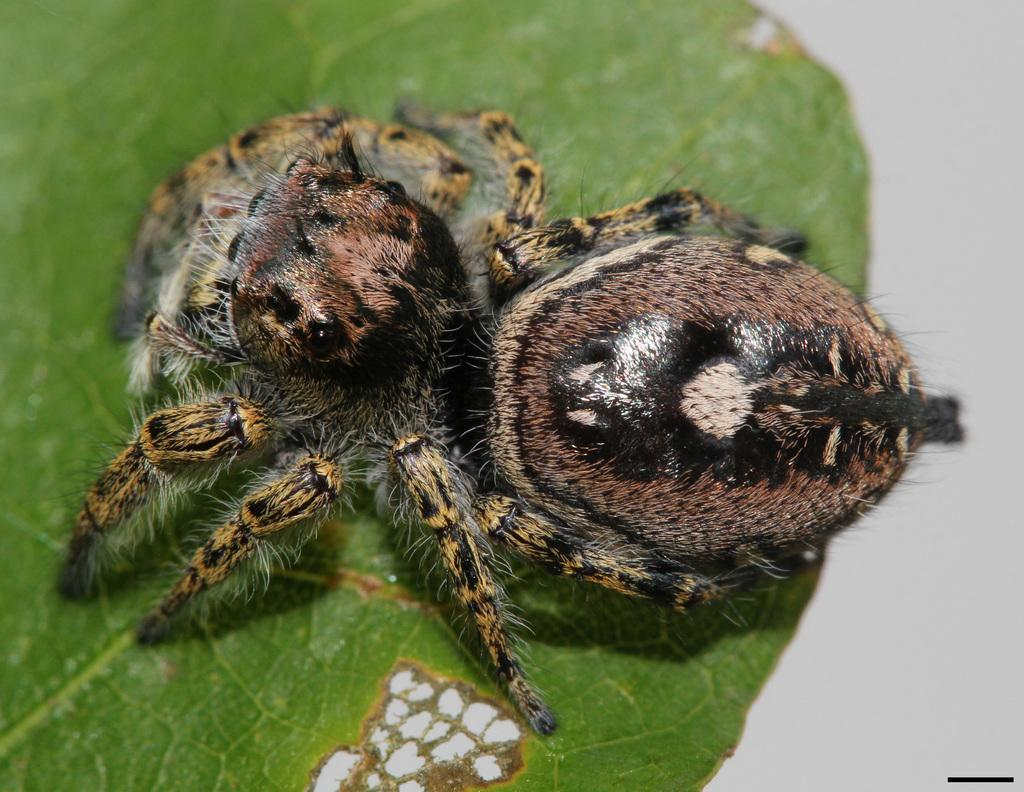What type of creatures are in the image? There are two insects in the image. Where are the insects located? The insects are on a leaf. What type of farm animals can be seen in the image? There are no farm animals present in the image; it features two insects on a leaf. What type of dinner is being served in the image? There is no dinner present in the image; it features two insects on a leaf. 